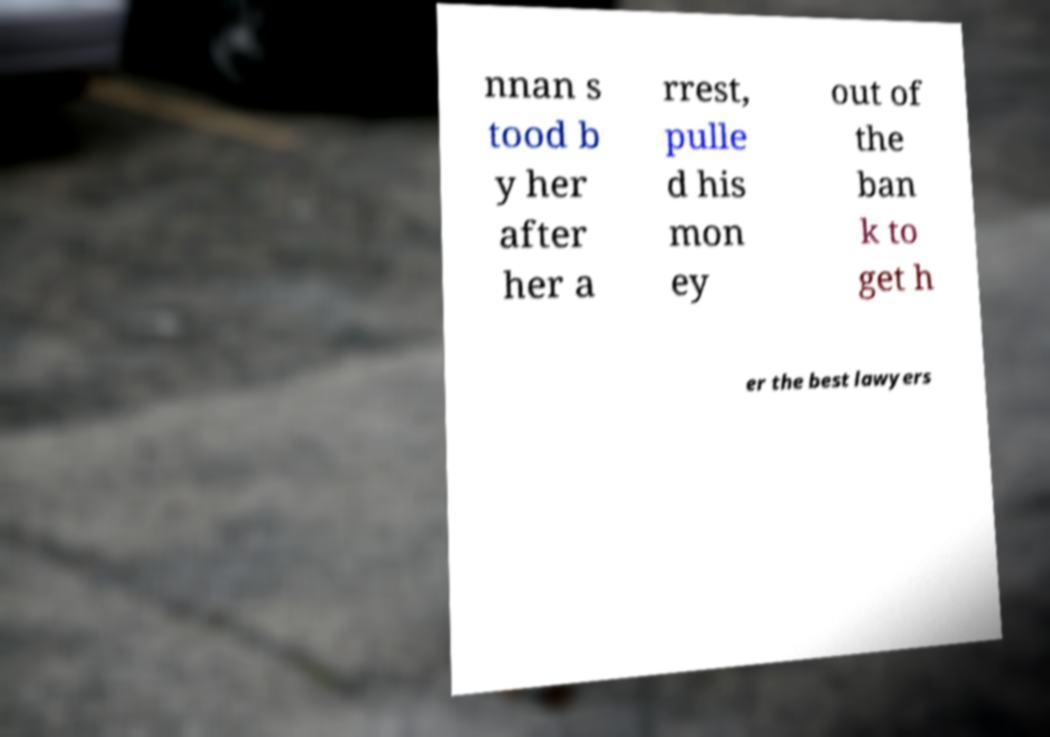Can you accurately transcribe the text from the provided image for me? nnan s tood b y her after her a rrest, pulle d his mon ey out of the ban k to get h er the best lawyers 